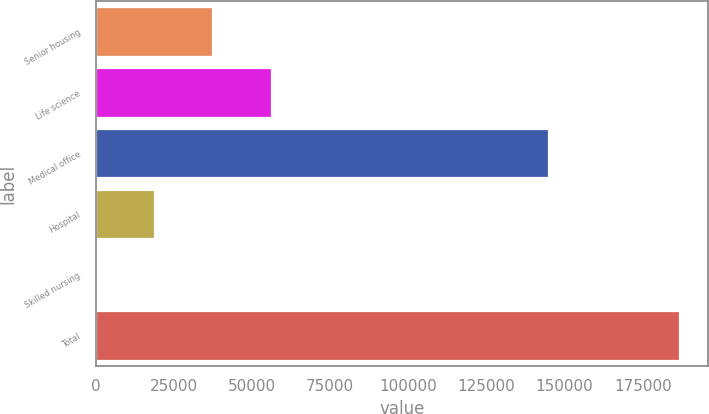Convert chart. <chart><loc_0><loc_0><loc_500><loc_500><bar_chart><fcel>Senior housing<fcel>Life science<fcel>Medical office<fcel>Hospital<fcel>Skilled nursing<fcel>Total<nl><fcel>37371.6<fcel>56018.9<fcel>144767<fcel>18724.3<fcel>77<fcel>186550<nl></chart> 